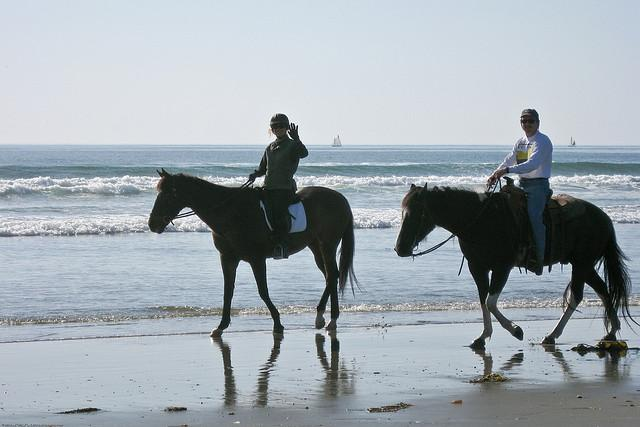Where do the riders here ride their horses?

Choices:
A) farm
B) vocano
C) inner city
D) sea shore sea shore 